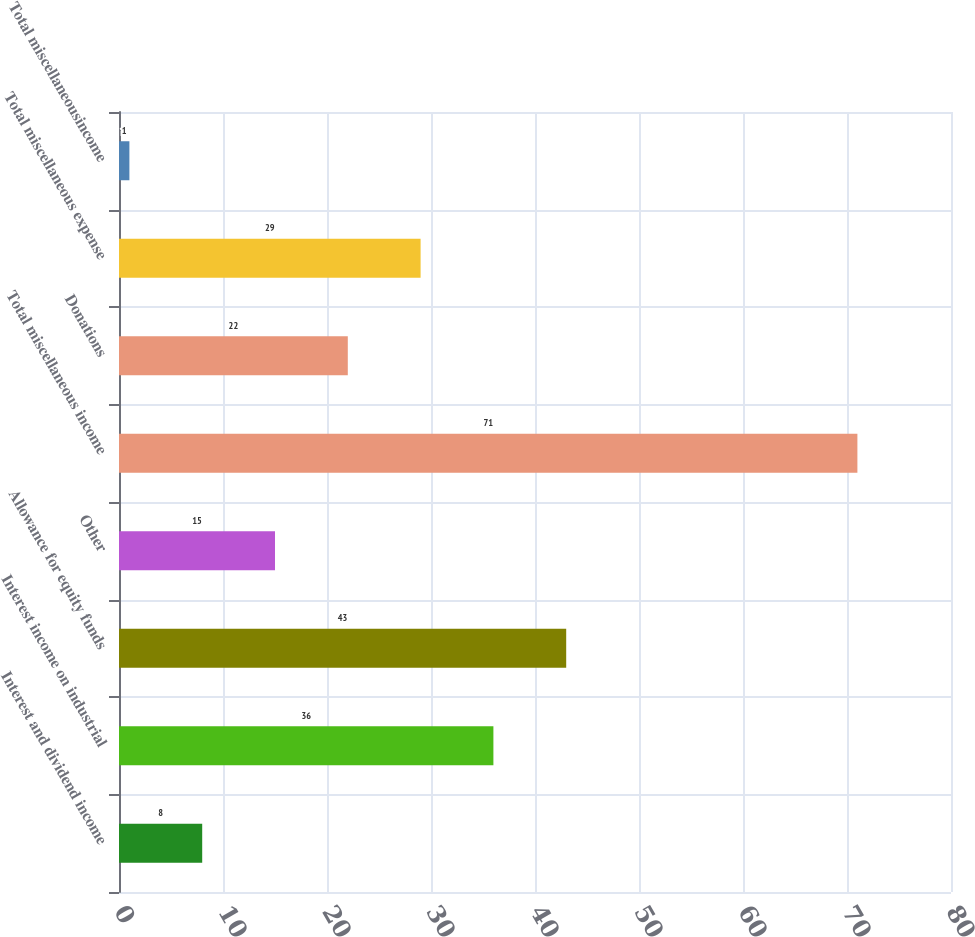Convert chart to OTSL. <chart><loc_0><loc_0><loc_500><loc_500><bar_chart><fcel>Interest and dividend income<fcel>Interest income on industrial<fcel>Allowance for equity funds<fcel>Other<fcel>Total miscellaneous income<fcel>Donations<fcel>Total miscellaneous expense<fcel>Total miscellaneousincome<nl><fcel>8<fcel>36<fcel>43<fcel>15<fcel>71<fcel>22<fcel>29<fcel>1<nl></chart> 